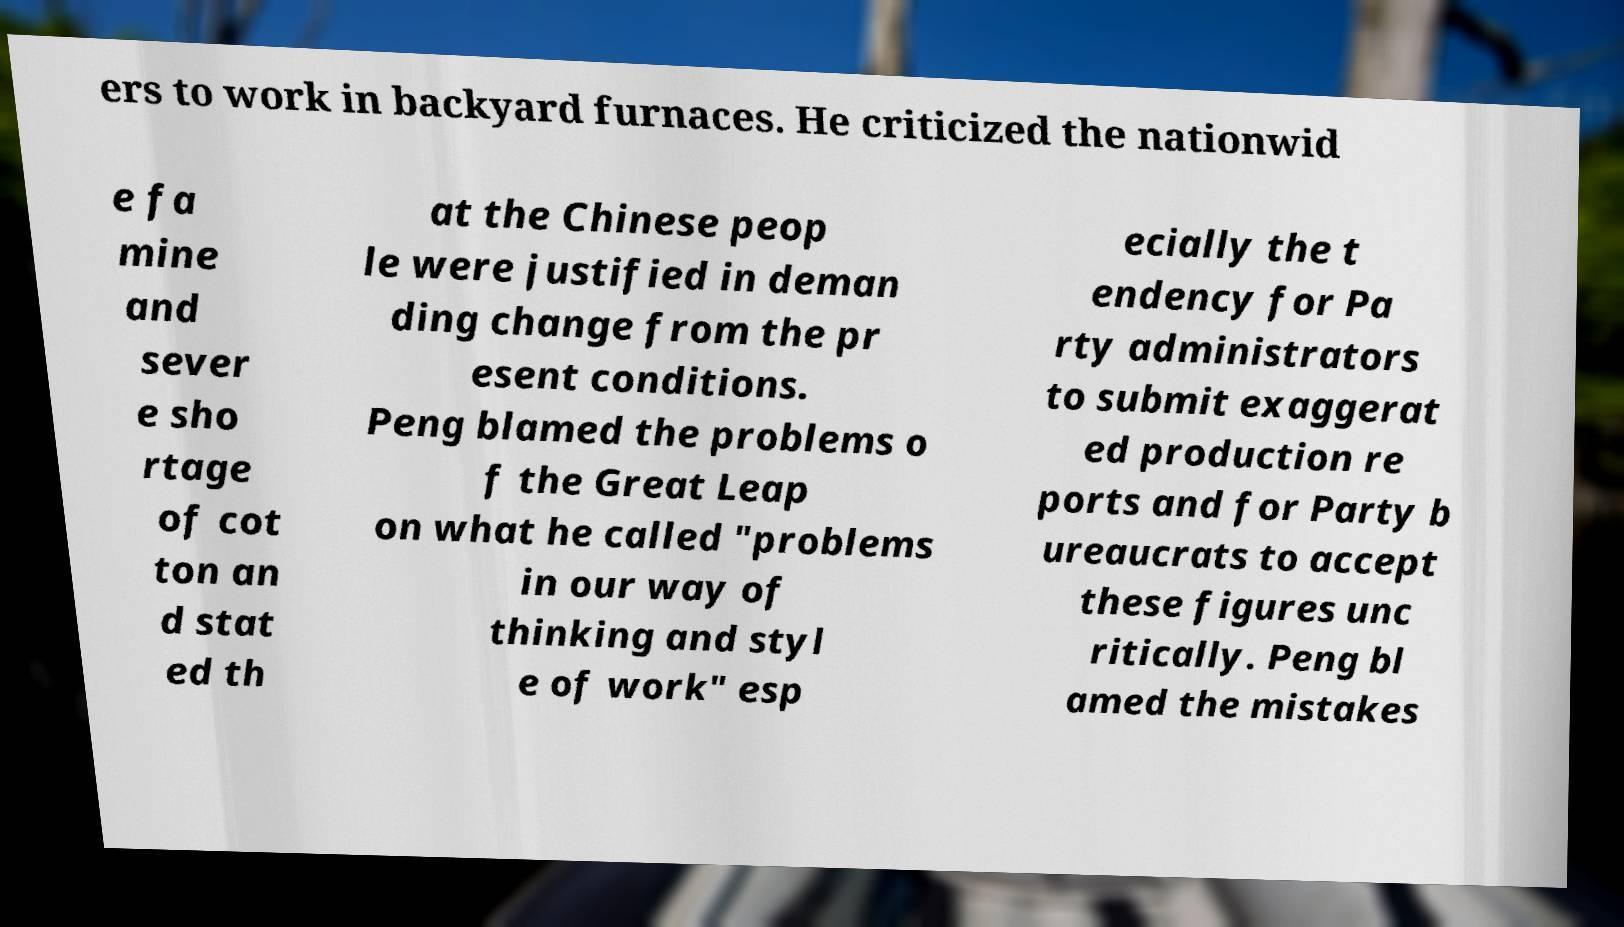Please read and relay the text visible in this image. What does it say? ers to work in backyard furnaces. He criticized the nationwid e fa mine and sever e sho rtage of cot ton an d stat ed th at the Chinese peop le were justified in deman ding change from the pr esent conditions. Peng blamed the problems o f the Great Leap on what he called "problems in our way of thinking and styl e of work" esp ecially the t endency for Pa rty administrators to submit exaggerat ed production re ports and for Party b ureaucrats to accept these figures unc ritically. Peng bl amed the mistakes 